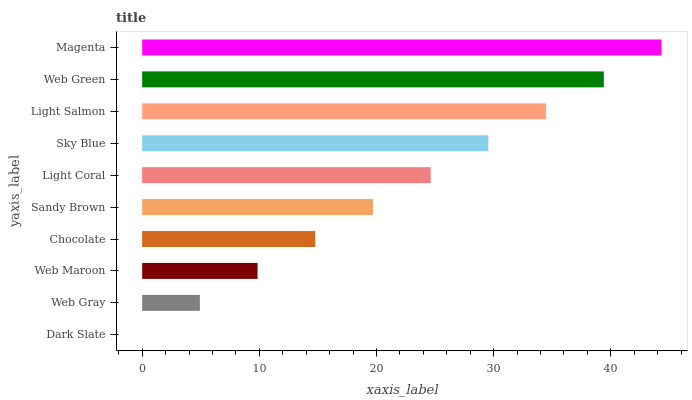Is Dark Slate the minimum?
Answer yes or no. Yes. Is Magenta the maximum?
Answer yes or no. Yes. Is Web Gray the minimum?
Answer yes or no. No. Is Web Gray the maximum?
Answer yes or no. No. Is Web Gray greater than Dark Slate?
Answer yes or no. Yes. Is Dark Slate less than Web Gray?
Answer yes or no. Yes. Is Dark Slate greater than Web Gray?
Answer yes or no. No. Is Web Gray less than Dark Slate?
Answer yes or no. No. Is Light Coral the high median?
Answer yes or no. Yes. Is Sandy Brown the low median?
Answer yes or no. Yes. Is Sky Blue the high median?
Answer yes or no. No. Is Web Green the low median?
Answer yes or no. No. 